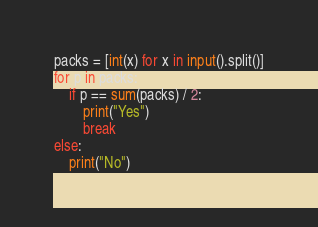Convert code to text. <code><loc_0><loc_0><loc_500><loc_500><_Python_>packs = [int(x) for x in input().split()]
for p in packs:
    if p == sum(packs) / 2:
        print("Yes")
        break
else:
    print("No")</code> 